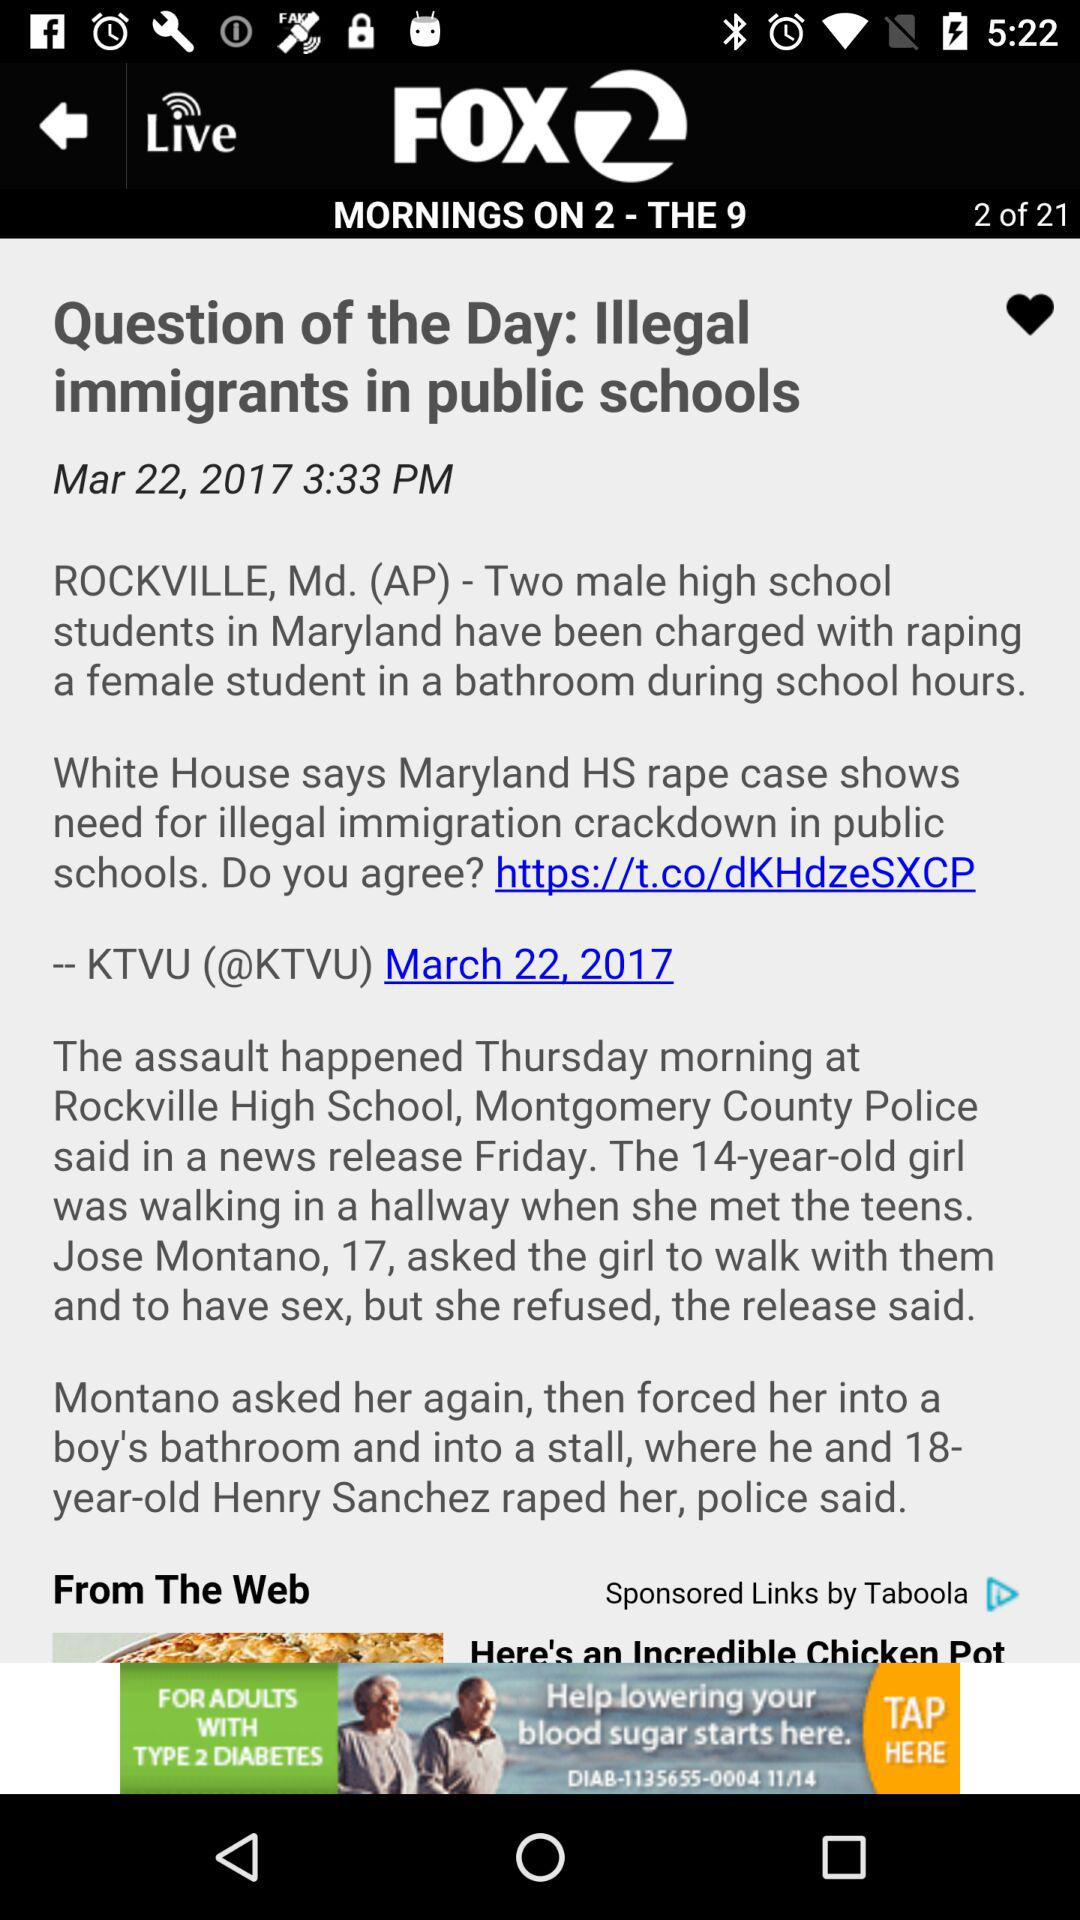What is the published time of the news? The published time of the news is 3:33 PM. 